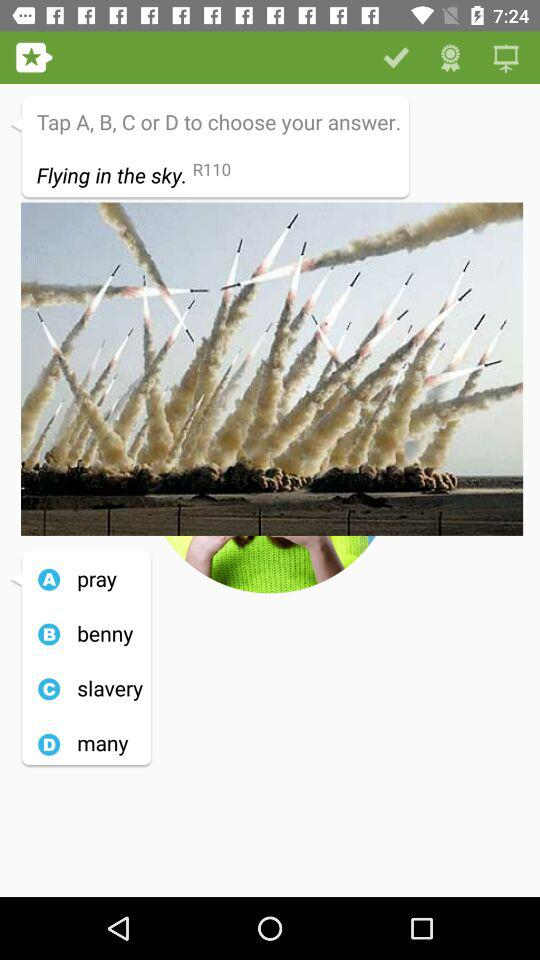What alphabet is for the "slavery" option? The alphabet for the "slavery" option is "C". 